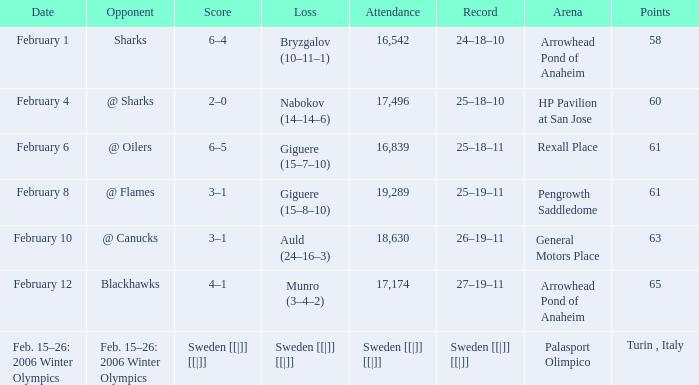What is the score when the points were 3-1, and the record was 25-19-11? 61.0. 